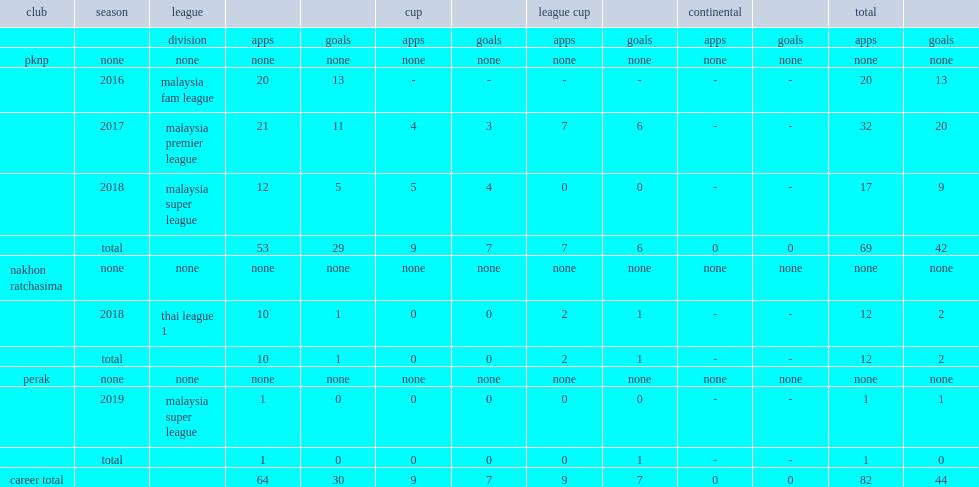Give me the full table as a dictionary. {'header': ['club', 'season', 'league', '', '', 'cup', '', 'league cup', '', 'continental', '', 'total', ''], 'rows': [['', '', 'division', 'apps', 'goals', 'apps', 'goals', 'apps', 'goals', 'apps', 'goals', 'apps', 'goals'], ['pknp', 'none', 'none', 'none', 'none', 'none', 'none', 'none', 'none', 'none', 'none', 'none', 'none'], ['', '2016', 'malaysia fam league', '20', '13', '-', '-', '-', '-', '-', '-', '20', '13'], ['', '2017', 'malaysia premier league', '21', '11', '4', '3', '7', '6', '-', '-', '32', '20'], ['', '2018', 'malaysia super league', '12', '5', '5', '4', '0', '0', '-', '-', '17', '9'], ['', 'total', '', '53', '29', '9', '7', '7', '6', '0', '0', '69', '42'], ['nakhon ratchasima', 'none', 'none', 'none', 'none', 'none', 'none', 'none', 'none', 'none', 'none', 'none', 'none'], ['', '2018', 'thai league 1', '10', '1', '0', '0', '2', '1', '-', '-', '12', '2'], ['', 'total', '', '10', '1', '0', '0', '2', '1', '-', '-', '12', '2'], ['perak', 'none', 'none', 'none', 'none', 'none', 'none', 'none', 'none', 'none', 'none', 'none', 'none'], ['', '2019', 'malaysia super league', '1', '0', '0', '0', '0', '0', '-', '-', '1', '1'], ['', 'total', '', '1', '0', '0', '0', '0', '1', '-', '-', '1', '0'], ['career total', '', '', '64', '30', '9', '7', '9', '7', '0', '0', '82', '44']]} Which club did shahrel join malaysia fam league in 2016? Pknp. 